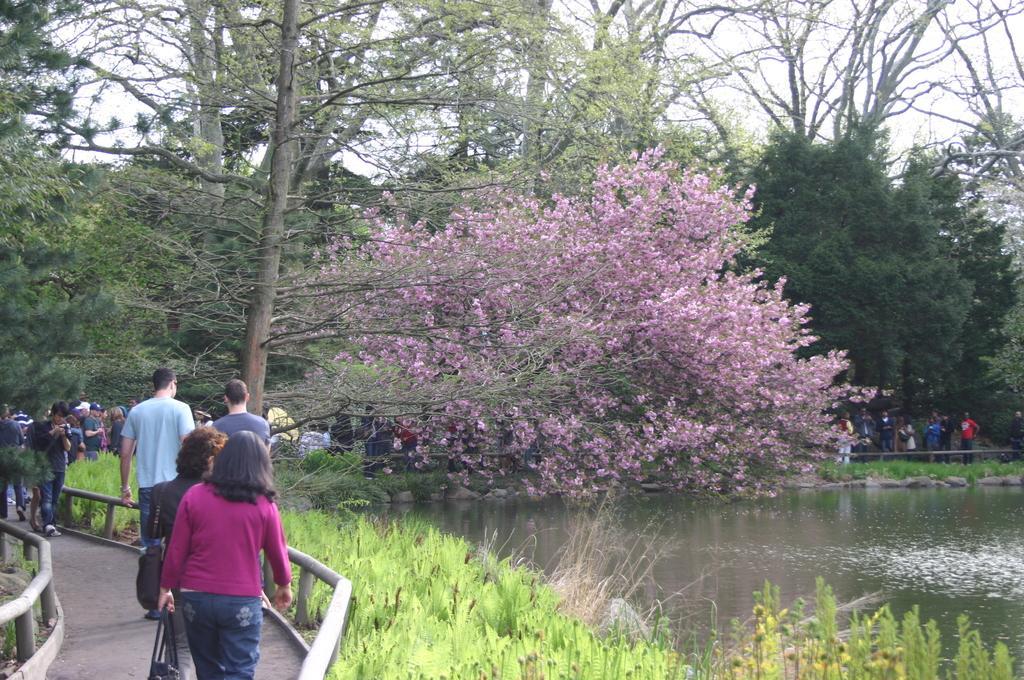Can you describe this image briefly? There are people, grass and a fence is present at the bottom of this image. We can see trees in the middle of this image. There is a surface of water and people present on the right side of this image and the sky is in the background. 